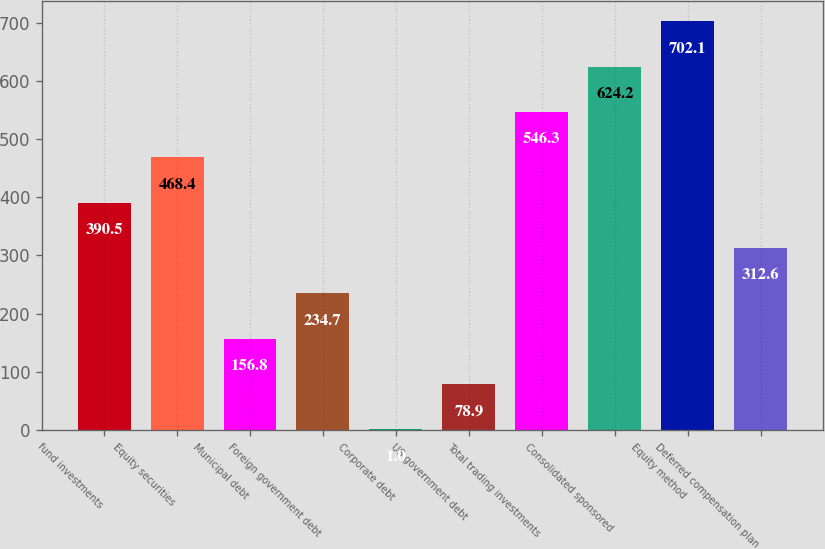Convert chart. <chart><loc_0><loc_0><loc_500><loc_500><bar_chart><fcel>fund investments<fcel>Equity securities<fcel>Municipal debt<fcel>Foreign government debt<fcel>Corporate debt<fcel>US government debt<fcel>Total trading investments<fcel>Consolidated sponsored<fcel>Equity method<fcel>Deferred compensation plan<nl><fcel>390.5<fcel>468.4<fcel>156.8<fcel>234.7<fcel>1<fcel>78.9<fcel>546.3<fcel>624.2<fcel>702.1<fcel>312.6<nl></chart> 